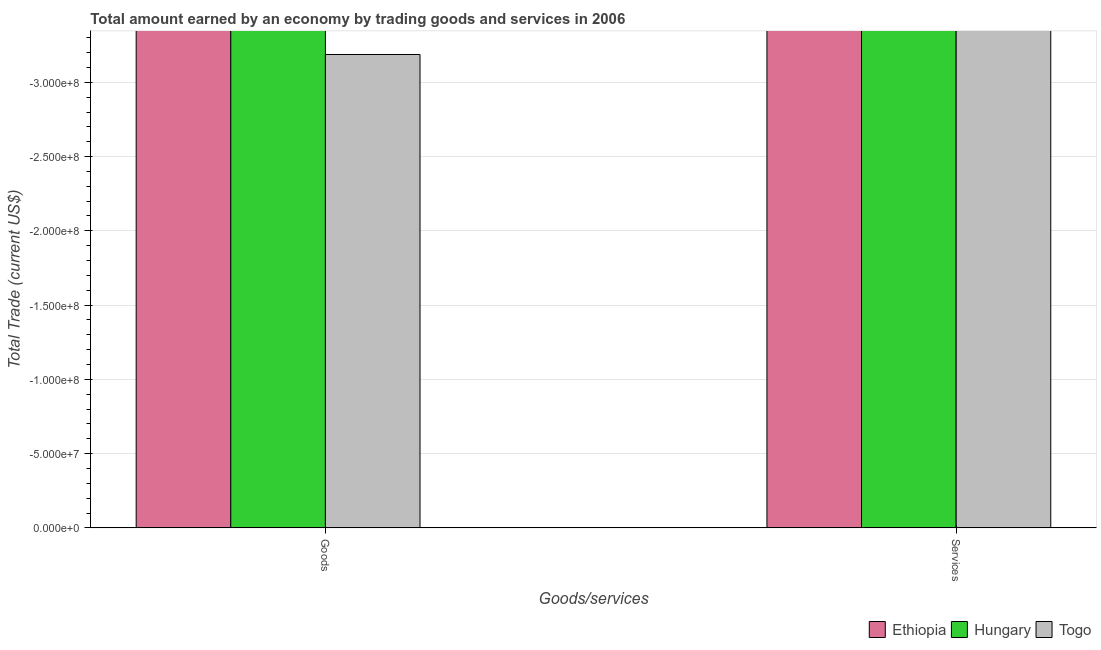How many bars are there on the 1st tick from the left?
Your response must be concise. 0. How many bars are there on the 2nd tick from the right?
Make the answer very short. 0. What is the label of the 1st group of bars from the left?
Give a very brief answer. Goods. What is the amount earned by trading services in Togo?
Provide a short and direct response. 0. What is the difference between the amount earned by trading services in Hungary and the amount earned by trading goods in Togo?
Your answer should be compact. 0. What is the average amount earned by trading goods per country?
Provide a short and direct response. 0. In how many countries, is the amount earned by trading services greater than -90000000 US$?
Provide a succinct answer. 0. Are all the bars in the graph horizontal?
Keep it short and to the point. No. How many countries are there in the graph?
Your response must be concise. 3. Are the values on the major ticks of Y-axis written in scientific E-notation?
Your answer should be very brief. Yes. Does the graph contain any zero values?
Provide a succinct answer. Yes. Does the graph contain grids?
Your answer should be very brief. Yes. Where does the legend appear in the graph?
Your answer should be very brief. Bottom right. How many legend labels are there?
Provide a short and direct response. 3. How are the legend labels stacked?
Your response must be concise. Horizontal. What is the title of the graph?
Keep it short and to the point. Total amount earned by an economy by trading goods and services in 2006. What is the label or title of the X-axis?
Make the answer very short. Goods/services. What is the label or title of the Y-axis?
Offer a very short reply. Total Trade (current US$). What is the Total Trade (current US$) of Hungary in Goods?
Your answer should be very brief. 0. What is the Total Trade (current US$) in Togo in Goods?
Your answer should be very brief. 0. What is the total Total Trade (current US$) of Ethiopia in the graph?
Offer a terse response. 0. What is the total Total Trade (current US$) in Hungary in the graph?
Make the answer very short. 0. 